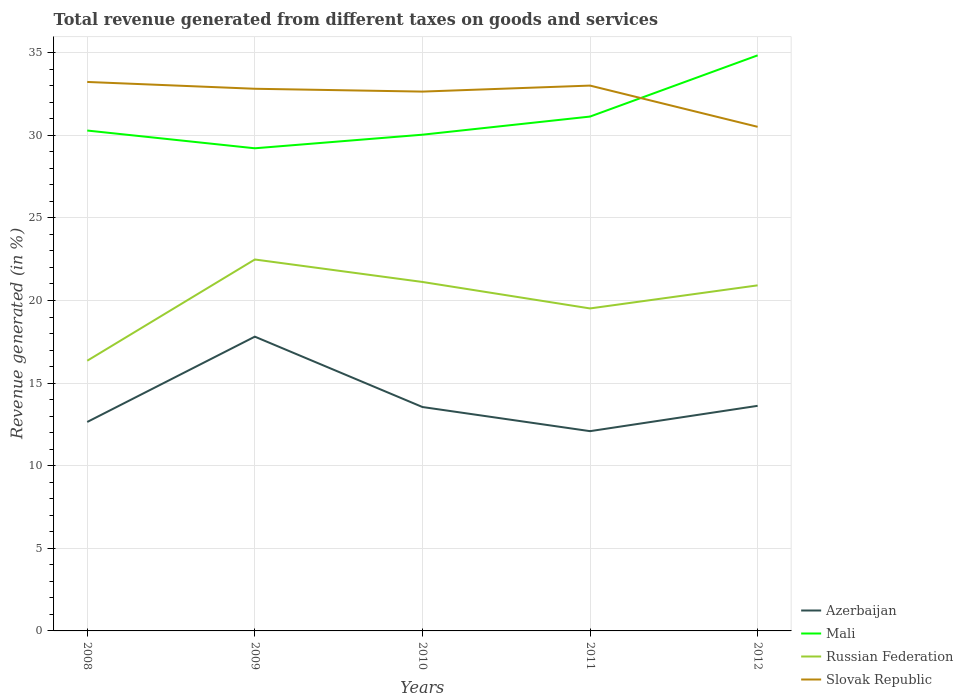How many different coloured lines are there?
Offer a very short reply. 4. Does the line corresponding to Russian Federation intersect with the line corresponding to Slovak Republic?
Keep it short and to the point. No. Across all years, what is the maximum total revenue generated in Mali?
Your answer should be compact. 29.21. In which year was the total revenue generated in Mali maximum?
Offer a very short reply. 2009. What is the total total revenue generated in Slovak Republic in the graph?
Keep it short and to the point. -0.19. What is the difference between the highest and the second highest total revenue generated in Russian Federation?
Ensure brevity in your answer.  6.13. How many lines are there?
Offer a terse response. 4. How many years are there in the graph?
Provide a short and direct response. 5. Are the values on the major ticks of Y-axis written in scientific E-notation?
Keep it short and to the point. No. Does the graph contain any zero values?
Offer a terse response. No. How many legend labels are there?
Keep it short and to the point. 4. How are the legend labels stacked?
Provide a succinct answer. Vertical. What is the title of the graph?
Provide a succinct answer. Total revenue generated from different taxes on goods and services. Does "Peru" appear as one of the legend labels in the graph?
Give a very brief answer. No. What is the label or title of the Y-axis?
Provide a short and direct response. Revenue generated (in %). What is the Revenue generated (in %) of Azerbaijan in 2008?
Your response must be concise. 12.65. What is the Revenue generated (in %) of Mali in 2008?
Offer a terse response. 30.29. What is the Revenue generated (in %) of Russian Federation in 2008?
Ensure brevity in your answer.  16.35. What is the Revenue generated (in %) of Slovak Republic in 2008?
Provide a short and direct response. 33.23. What is the Revenue generated (in %) of Azerbaijan in 2009?
Ensure brevity in your answer.  17.81. What is the Revenue generated (in %) in Mali in 2009?
Keep it short and to the point. 29.21. What is the Revenue generated (in %) of Russian Federation in 2009?
Make the answer very short. 22.48. What is the Revenue generated (in %) of Slovak Republic in 2009?
Keep it short and to the point. 32.82. What is the Revenue generated (in %) in Azerbaijan in 2010?
Make the answer very short. 13.55. What is the Revenue generated (in %) of Mali in 2010?
Your response must be concise. 30.04. What is the Revenue generated (in %) of Russian Federation in 2010?
Provide a succinct answer. 21.12. What is the Revenue generated (in %) in Slovak Republic in 2010?
Your response must be concise. 32.65. What is the Revenue generated (in %) in Azerbaijan in 2011?
Ensure brevity in your answer.  12.09. What is the Revenue generated (in %) in Mali in 2011?
Offer a very short reply. 31.13. What is the Revenue generated (in %) of Russian Federation in 2011?
Your answer should be very brief. 19.52. What is the Revenue generated (in %) of Slovak Republic in 2011?
Make the answer very short. 33.01. What is the Revenue generated (in %) in Azerbaijan in 2012?
Give a very brief answer. 13.63. What is the Revenue generated (in %) of Mali in 2012?
Provide a succinct answer. 34.84. What is the Revenue generated (in %) of Russian Federation in 2012?
Your answer should be very brief. 20.92. What is the Revenue generated (in %) of Slovak Republic in 2012?
Provide a succinct answer. 30.51. Across all years, what is the maximum Revenue generated (in %) in Azerbaijan?
Provide a succinct answer. 17.81. Across all years, what is the maximum Revenue generated (in %) of Mali?
Offer a terse response. 34.84. Across all years, what is the maximum Revenue generated (in %) of Russian Federation?
Your answer should be compact. 22.48. Across all years, what is the maximum Revenue generated (in %) in Slovak Republic?
Offer a terse response. 33.23. Across all years, what is the minimum Revenue generated (in %) of Azerbaijan?
Offer a very short reply. 12.09. Across all years, what is the minimum Revenue generated (in %) of Mali?
Your answer should be compact. 29.21. Across all years, what is the minimum Revenue generated (in %) of Russian Federation?
Your answer should be compact. 16.35. Across all years, what is the minimum Revenue generated (in %) of Slovak Republic?
Your response must be concise. 30.51. What is the total Revenue generated (in %) in Azerbaijan in the graph?
Offer a very short reply. 69.73. What is the total Revenue generated (in %) in Mali in the graph?
Your answer should be very brief. 155.51. What is the total Revenue generated (in %) in Russian Federation in the graph?
Offer a terse response. 100.4. What is the total Revenue generated (in %) of Slovak Republic in the graph?
Make the answer very short. 162.21. What is the difference between the Revenue generated (in %) of Azerbaijan in 2008 and that in 2009?
Make the answer very short. -5.16. What is the difference between the Revenue generated (in %) of Mali in 2008 and that in 2009?
Provide a short and direct response. 1.07. What is the difference between the Revenue generated (in %) in Russian Federation in 2008 and that in 2009?
Give a very brief answer. -6.13. What is the difference between the Revenue generated (in %) of Slovak Republic in 2008 and that in 2009?
Offer a very short reply. 0.41. What is the difference between the Revenue generated (in %) in Azerbaijan in 2008 and that in 2010?
Offer a very short reply. -0.91. What is the difference between the Revenue generated (in %) in Mali in 2008 and that in 2010?
Give a very brief answer. 0.25. What is the difference between the Revenue generated (in %) in Russian Federation in 2008 and that in 2010?
Ensure brevity in your answer.  -4.77. What is the difference between the Revenue generated (in %) in Slovak Republic in 2008 and that in 2010?
Offer a very short reply. 0.58. What is the difference between the Revenue generated (in %) of Azerbaijan in 2008 and that in 2011?
Give a very brief answer. 0.56. What is the difference between the Revenue generated (in %) of Mali in 2008 and that in 2011?
Give a very brief answer. -0.85. What is the difference between the Revenue generated (in %) in Russian Federation in 2008 and that in 2011?
Your answer should be very brief. -3.17. What is the difference between the Revenue generated (in %) in Slovak Republic in 2008 and that in 2011?
Offer a very short reply. 0.22. What is the difference between the Revenue generated (in %) in Azerbaijan in 2008 and that in 2012?
Your answer should be compact. -0.98. What is the difference between the Revenue generated (in %) of Mali in 2008 and that in 2012?
Your response must be concise. -4.55. What is the difference between the Revenue generated (in %) of Russian Federation in 2008 and that in 2012?
Keep it short and to the point. -4.56. What is the difference between the Revenue generated (in %) in Slovak Republic in 2008 and that in 2012?
Your response must be concise. 2.72. What is the difference between the Revenue generated (in %) in Azerbaijan in 2009 and that in 2010?
Ensure brevity in your answer.  4.26. What is the difference between the Revenue generated (in %) of Mali in 2009 and that in 2010?
Keep it short and to the point. -0.82. What is the difference between the Revenue generated (in %) in Russian Federation in 2009 and that in 2010?
Ensure brevity in your answer.  1.36. What is the difference between the Revenue generated (in %) in Slovak Republic in 2009 and that in 2010?
Your response must be concise. 0.17. What is the difference between the Revenue generated (in %) in Azerbaijan in 2009 and that in 2011?
Keep it short and to the point. 5.72. What is the difference between the Revenue generated (in %) in Mali in 2009 and that in 2011?
Make the answer very short. -1.92. What is the difference between the Revenue generated (in %) in Russian Federation in 2009 and that in 2011?
Provide a succinct answer. 2.96. What is the difference between the Revenue generated (in %) of Slovak Republic in 2009 and that in 2011?
Provide a succinct answer. -0.19. What is the difference between the Revenue generated (in %) in Azerbaijan in 2009 and that in 2012?
Give a very brief answer. 4.19. What is the difference between the Revenue generated (in %) in Mali in 2009 and that in 2012?
Offer a terse response. -5.62. What is the difference between the Revenue generated (in %) of Russian Federation in 2009 and that in 2012?
Ensure brevity in your answer.  1.56. What is the difference between the Revenue generated (in %) in Slovak Republic in 2009 and that in 2012?
Provide a succinct answer. 2.3. What is the difference between the Revenue generated (in %) of Azerbaijan in 2010 and that in 2011?
Give a very brief answer. 1.46. What is the difference between the Revenue generated (in %) in Mali in 2010 and that in 2011?
Give a very brief answer. -1.1. What is the difference between the Revenue generated (in %) in Russian Federation in 2010 and that in 2011?
Keep it short and to the point. 1.6. What is the difference between the Revenue generated (in %) of Slovak Republic in 2010 and that in 2011?
Your answer should be very brief. -0.36. What is the difference between the Revenue generated (in %) in Azerbaijan in 2010 and that in 2012?
Your answer should be very brief. -0.07. What is the difference between the Revenue generated (in %) in Mali in 2010 and that in 2012?
Keep it short and to the point. -4.8. What is the difference between the Revenue generated (in %) in Russian Federation in 2010 and that in 2012?
Your response must be concise. 0.2. What is the difference between the Revenue generated (in %) in Slovak Republic in 2010 and that in 2012?
Give a very brief answer. 2.13. What is the difference between the Revenue generated (in %) of Azerbaijan in 2011 and that in 2012?
Give a very brief answer. -1.53. What is the difference between the Revenue generated (in %) in Mali in 2011 and that in 2012?
Make the answer very short. -3.7. What is the difference between the Revenue generated (in %) of Russian Federation in 2011 and that in 2012?
Give a very brief answer. -1.4. What is the difference between the Revenue generated (in %) of Slovak Republic in 2011 and that in 2012?
Your response must be concise. 2.5. What is the difference between the Revenue generated (in %) of Azerbaijan in 2008 and the Revenue generated (in %) of Mali in 2009?
Give a very brief answer. -16.57. What is the difference between the Revenue generated (in %) of Azerbaijan in 2008 and the Revenue generated (in %) of Russian Federation in 2009?
Give a very brief answer. -9.83. What is the difference between the Revenue generated (in %) in Azerbaijan in 2008 and the Revenue generated (in %) in Slovak Republic in 2009?
Offer a very short reply. -20.17. What is the difference between the Revenue generated (in %) in Mali in 2008 and the Revenue generated (in %) in Russian Federation in 2009?
Offer a terse response. 7.81. What is the difference between the Revenue generated (in %) of Mali in 2008 and the Revenue generated (in %) of Slovak Republic in 2009?
Give a very brief answer. -2.53. What is the difference between the Revenue generated (in %) of Russian Federation in 2008 and the Revenue generated (in %) of Slovak Republic in 2009?
Your answer should be very brief. -16.46. What is the difference between the Revenue generated (in %) in Azerbaijan in 2008 and the Revenue generated (in %) in Mali in 2010?
Make the answer very short. -17.39. What is the difference between the Revenue generated (in %) of Azerbaijan in 2008 and the Revenue generated (in %) of Russian Federation in 2010?
Your answer should be very brief. -8.47. What is the difference between the Revenue generated (in %) of Azerbaijan in 2008 and the Revenue generated (in %) of Slovak Republic in 2010?
Provide a short and direct response. -20. What is the difference between the Revenue generated (in %) in Mali in 2008 and the Revenue generated (in %) in Russian Federation in 2010?
Provide a short and direct response. 9.17. What is the difference between the Revenue generated (in %) of Mali in 2008 and the Revenue generated (in %) of Slovak Republic in 2010?
Offer a terse response. -2.36. What is the difference between the Revenue generated (in %) in Russian Federation in 2008 and the Revenue generated (in %) in Slovak Republic in 2010?
Provide a succinct answer. -16.29. What is the difference between the Revenue generated (in %) in Azerbaijan in 2008 and the Revenue generated (in %) in Mali in 2011?
Provide a succinct answer. -18.49. What is the difference between the Revenue generated (in %) of Azerbaijan in 2008 and the Revenue generated (in %) of Russian Federation in 2011?
Ensure brevity in your answer.  -6.87. What is the difference between the Revenue generated (in %) of Azerbaijan in 2008 and the Revenue generated (in %) of Slovak Republic in 2011?
Offer a terse response. -20.36. What is the difference between the Revenue generated (in %) of Mali in 2008 and the Revenue generated (in %) of Russian Federation in 2011?
Ensure brevity in your answer.  10.77. What is the difference between the Revenue generated (in %) in Mali in 2008 and the Revenue generated (in %) in Slovak Republic in 2011?
Offer a terse response. -2.72. What is the difference between the Revenue generated (in %) in Russian Federation in 2008 and the Revenue generated (in %) in Slovak Republic in 2011?
Your answer should be very brief. -16.65. What is the difference between the Revenue generated (in %) of Azerbaijan in 2008 and the Revenue generated (in %) of Mali in 2012?
Offer a very short reply. -22.19. What is the difference between the Revenue generated (in %) of Azerbaijan in 2008 and the Revenue generated (in %) of Russian Federation in 2012?
Keep it short and to the point. -8.27. What is the difference between the Revenue generated (in %) in Azerbaijan in 2008 and the Revenue generated (in %) in Slovak Republic in 2012?
Your answer should be very brief. -17.87. What is the difference between the Revenue generated (in %) of Mali in 2008 and the Revenue generated (in %) of Russian Federation in 2012?
Your answer should be very brief. 9.37. What is the difference between the Revenue generated (in %) of Mali in 2008 and the Revenue generated (in %) of Slovak Republic in 2012?
Make the answer very short. -0.23. What is the difference between the Revenue generated (in %) in Russian Federation in 2008 and the Revenue generated (in %) in Slovak Republic in 2012?
Ensure brevity in your answer.  -14.16. What is the difference between the Revenue generated (in %) in Azerbaijan in 2009 and the Revenue generated (in %) in Mali in 2010?
Your response must be concise. -12.22. What is the difference between the Revenue generated (in %) of Azerbaijan in 2009 and the Revenue generated (in %) of Russian Federation in 2010?
Your response must be concise. -3.31. What is the difference between the Revenue generated (in %) of Azerbaijan in 2009 and the Revenue generated (in %) of Slovak Republic in 2010?
Offer a very short reply. -14.83. What is the difference between the Revenue generated (in %) of Mali in 2009 and the Revenue generated (in %) of Russian Federation in 2010?
Keep it short and to the point. 8.09. What is the difference between the Revenue generated (in %) of Mali in 2009 and the Revenue generated (in %) of Slovak Republic in 2010?
Your answer should be compact. -3.43. What is the difference between the Revenue generated (in %) in Russian Federation in 2009 and the Revenue generated (in %) in Slovak Republic in 2010?
Ensure brevity in your answer.  -10.16. What is the difference between the Revenue generated (in %) in Azerbaijan in 2009 and the Revenue generated (in %) in Mali in 2011?
Offer a very short reply. -13.32. What is the difference between the Revenue generated (in %) in Azerbaijan in 2009 and the Revenue generated (in %) in Russian Federation in 2011?
Keep it short and to the point. -1.71. What is the difference between the Revenue generated (in %) in Azerbaijan in 2009 and the Revenue generated (in %) in Slovak Republic in 2011?
Your response must be concise. -15.2. What is the difference between the Revenue generated (in %) in Mali in 2009 and the Revenue generated (in %) in Russian Federation in 2011?
Your answer should be compact. 9.69. What is the difference between the Revenue generated (in %) in Mali in 2009 and the Revenue generated (in %) in Slovak Republic in 2011?
Offer a very short reply. -3.8. What is the difference between the Revenue generated (in %) of Russian Federation in 2009 and the Revenue generated (in %) of Slovak Republic in 2011?
Ensure brevity in your answer.  -10.53. What is the difference between the Revenue generated (in %) in Azerbaijan in 2009 and the Revenue generated (in %) in Mali in 2012?
Your answer should be very brief. -17.03. What is the difference between the Revenue generated (in %) in Azerbaijan in 2009 and the Revenue generated (in %) in Russian Federation in 2012?
Offer a terse response. -3.11. What is the difference between the Revenue generated (in %) of Azerbaijan in 2009 and the Revenue generated (in %) of Slovak Republic in 2012?
Give a very brief answer. -12.7. What is the difference between the Revenue generated (in %) in Mali in 2009 and the Revenue generated (in %) in Russian Federation in 2012?
Your answer should be very brief. 8.3. What is the difference between the Revenue generated (in %) of Mali in 2009 and the Revenue generated (in %) of Slovak Republic in 2012?
Give a very brief answer. -1.3. What is the difference between the Revenue generated (in %) in Russian Federation in 2009 and the Revenue generated (in %) in Slovak Republic in 2012?
Give a very brief answer. -8.03. What is the difference between the Revenue generated (in %) in Azerbaijan in 2010 and the Revenue generated (in %) in Mali in 2011?
Make the answer very short. -17.58. What is the difference between the Revenue generated (in %) in Azerbaijan in 2010 and the Revenue generated (in %) in Russian Federation in 2011?
Ensure brevity in your answer.  -5.97. What is the difference between the Revenue generated (in %) in Azerbaijan in 2010 and the Revenue generated (in %) in Slovak Republic in 2011?
Your answer should be compact. -19.46. What is the difference between the Revenue generated (in %) of Mali in 2010 and the Revenue generated (in %) of Russian Federation in 2011?
Offer a terse response. 10.52. What is the difference between the Revenue generated (in %) in Mali in 2010 and the Revenue generated (in %) in Slovak Republic in 2011?
Ensure brevity in your answer.  -2.97. What is the difference between the Revenue generated (in %) of Russian Federation in 2010 and the Revenue generated (in %) of Slovak Republic in 2011?
Give a very brief answer. -11.89. What is the difference between the Revenue generated (in %) in Azerbaijan in 2010 and the Revenue generated (in %) in Mali in 2012?
Your response must be concise. -21.29. What is the difference between the Revenue generated (in %) in Azerbaijan in 2010 and the Revenue generated (in %) in Russian Federation in 2012?
Your response must be concise. -7.36. What is the difference between the Revenue generated (in %) in Azerbaijan in 2010 and the Revenue generated (in %) in Slovak Republic in 2012?
Make the answer very short. -16.96. What is the difference between the Revenue generated (in %) of Mali in 2010 and the Revenue generated (in %) of Russian Federation in 2012?
Provide a succinct answer. 9.12. What is the difference between the Revenue generated (in %) of Mali in 2010 and the Revenue generated (in %) of Slovak Republic in 2012?
Provide a short and direct response. -0.48. What is the difference between the Revenue generated (in %) in Russian Federation in 2010 and the Revenue generated (in %) in Slovak Republic in 2012?
Provide a succinct answer. -9.39. What is the difference between the Revenue generated (in %) in Azerbaijan in 2011 and the Revenue generated (in %) in Mali in 2012?
Your answer should be compact. -22.75. What is the difference between the Revenue generated (in %) in Azerbaijan in 2011 and the Revenue generated (in %) in Russian Federation in 2012?
Provide a succinct answer. -8.83. What is the difference between the Revenue generated (in %) in Azerbaijan in 2011 and the Revenue generated (in %) in Slovak Republic in 2012?
Your answer should be compact. -18.42. What is the difference between the Revenue generated (in %) of Mali in 2011 and the Revenue generated (in %) of Russian Federation in 2012?
Provide a short and direct response. 10.22. What is the difference between the Revenue generated (in %) in Mali in 2011 and the Revenue generated (in %) in Slovak Republic in 2012?
Your answer should be compact. 0.62. What is the difference between the Revenue generated (in %) in Russian Federation in 2011 and the Revenue generated (in %) in Slovak Republic in 2012?
Offer a very short reply. -10.99. What is the average Revenue generated (in %) of Azerbaijan per year?
Make the answer very short. 13.95. What is the average Revenue generated (in %) in Mali per year?
Give a very brief answer. 31.1. What is the average Revenue generated (in %) in Russian Federation per year?
Give a very brief answer. 20.08. What is the average Revenue generated (in %) in Slovak Republic per year?
Offer a very short reply. 32.44. In the year 2008, what is the difference between the Revenue generated (in %) of Azerbaijan and Revenue generated (in %) of Mali?
Ensure brevity in your answer.  -17.64. In the year 2008, what is the difference between the Revenue generated (in %) of Azerbaijan and Revenue generated (in %) of Russian Federation?
Provide a succinct answer. -3.71. In the year 2008, what is the difference between the Revenue generated (in %) in Azerbaijan and Revenue generated (in %) in Slovak Republic?
Provide a short and direct response. -20.58. In the year 2008, what is the difference between the Revenue generated (in %) of Mali and Revenue generated (in %) of Russian Federation?
Provide a succinct answer. 13.93. In the year 2008, what is the difference between the Revenue generated (in %) of Mali and Revenue generated (in %) of Slovak Republic?
Offer a terse response. -2.94. In the year 2008, what is the difference between the Revenue generated (in %) in Russian Federation and Revenue generated (in %) in Slovak Republic?
Give a very brief answer. -16.87. In the year 2009, what is the difference between the Revenue generated (in %) of Azerbaijan and Revenue generated (in %) of Mali?
Ensure brevity in your answer.  -11.4. In the year 2009, what is the difference between the Revenue generated (in %) in Azerbaijan and Revenue generated (in %) in Russian Federation?
Make the answer very short. -4.67. In the year 2009, what is the difference between the Revenue generated (in %) in Azerbaijan and Revenue generated (in %) in Slovak Republic?
Offer a terse response. -15. In the year 2009, what is the difference between the Revenue generated (in %) in Mali and Revenue generated (in %) in Russian Federation?
Provide a short and direct response. 6.73. In the year 2009, what is the difference between the Revenue generated (in %) of Mali and Revenue generated (in %) of Slovak Republic?
Give a very brief answer. -3.6. In the year 2009, what is the difference between the Revenue generated (in %) in Russian Federation and Revenue generated (in %) in Slovak Republic?
Provide a short and direct response. -10.33. In the year 2010, what is the difference between the Revenue generated (in %) of Azerbaijan and Revenue generated (in %) of Mali?
Make the answer very short. -16.48. In the year 2010, what is the difference between the Revenue generated (in %) in Azerbaijan and Revenue generated (in %) in Russian Federation?
Provide a succinct answer. -7.57. In the year 2010, what is the difference between the Revenue generated (in %) of Azerbaijan and Revenue generated (in %) of Slovak Republic?
Ensure brevity in your answer.  -19.09. In the year 2010, what is the difference between the Revenue generated (in %) in Mali and Revenue generated (in %) in Russian Federation?
Provide a succinct answer. 8.91. In the year 2010, what is the difference between the Revenue generated (in %) in Mali and Revenue generated (in %) in Slovak Republic?
Your answer should be very brief. -2.61. In the year 2010, what is the difference between the Revenue generated (in %) of Russian Federation and Revenue generated (in %) of Slovak Republic?
Provide a short and direct response. -11.52. In the year 2011, what is the difference between the Revenue generated (in %) in Azerbaijan and Revenue generated (in %) in Mali?
Offer a very short reply. -19.04. In the year 2011, what is the difference between the Revenue generated (in %) in Azerbaijan and Revenue generated (in %) in Russian Federation?
Offer a very short reply. -7.43. In the year 2011, what is the difference between the Revenue generated (in %) of Azerbaijan and Revenue generated (in %) of Slovak Republic?
Keep it short and to the point. -20.92. In the year 2011, what is the difference between the Revenue generated (in %) in Mali and Revenue generated (in %) in Russian Federation?
Keep it short and to the point. 11.61. In the year 2011, what is the difference between the Revenue generated (in %) of Mali and Revenue generated (in %) of Slovak Republic?
Keep it short and to the point. -1.88. In the year 2011, what is the difference between the Revenue generated (in %) of Russian Federation and Revenue generated (in %) of Slovak Republic?
Offer a terse response. -13.49. In the year 2012, what is the difference between the Revenue generated (in %) of Azerbaijan and Revenue generated (in %) of Mali?
Your answer should be compact. -21.21. In the year 2012, what is the difference between the Revenue generated (in %) in Azerbaijan and Revenue generated (in %) in Russian Federation?
Provide a succinct answer. -7.29. In the year 2012, what is the difference between the Revenue generated (in %) of Azerbaijan and Revenue generated (in %) of Slovak Republic?
Your response must be concise. -16.89. In the year 2012, what is the difference between the Revenue generated (in %) in Mali and Revenue generated (in %) in Russian Federation?
Make the answer very short. 13.92. In the year 2012, what is the difference between the Revenue generated (in %) in Mali and Revenue generated (in %) in Slovak Republic?
Your answer should be very brief. 4.32. In the year 2012, what is the difference between the Revenue generated (in %) of Russian Federation and Revenue generated (in %) of Slovak Republic?
Ensure brevity in your answer.  -9.6. What is the ratio of the Revenue generated (in %) of Azerbaijan in 2008 to that in 2009?
Provide a succinct answer. 0.71. What is the ratio of the Revenue generated (in %) in Mali in 2008 to that in 2009?
Offer a very short reply. 1.04. What is the ratio of the Revenue generated (in %) of Russian Federation in 2008 to that in 2009?
Give a very brief answer. 0.73. What is the ratio of the Revenue generated (in %) of Slovak Republic in 2008 to that in 2009?
Give a very brief answer. 1.01. What is the ratio of the Revenue generated (in %) in Azerbaijan in 2008 to that in 2010?
Your answer should be very brief. 0.93. What is the ratio of the Revenue generated (in %) in Mali in 2008 to that in 2010?
Your response must be concise. 1.01. What is the ratio of the Revenue generated (in %) in Russian Federation in 2008 to that in 2010?
Make the answer very short. 0.77. What is the ratio of the Revenue generated (in %) of Slovak Republic in 2008 to that in 2010?
Ensure brevity in your answer.  1.02. What is the ratio of the Revenue generated (in %) in Azerbaijan in 2008 to that in 2011?
Give a very brief answer. 1.05. What is the ratio of the Revenue generated (in %) of Mali in 2008 to that in 2011?
Your answer should be compact. 0.97. What is the ratio of the Revenue generated (in %) of Russian Federation in 2008 to that in 2011?
Make the answer very short. 0.84. What is the ratio of the Revenue generated (in %) in Slovak Republic in 2008 to that in 2011?
Provide a short and direct response. 1.01. What is the ratio of the Revenue generated (in %) of Azerbaijan in 2008 to that in 2012?
Keep it short and to the point. 0.93. What is the ratio of the Revenue generated (in %) in Mali in 2008 to that in 2012?
Your response must be concise. 0.87. What is the ratio of the Revenue generated (in %) in Russian Federation in 2008 to that in 2012?
Your answer should be very brief. 0.78. What is the ratio of the Revenue generated (in %) of Slovak Republic in 2008 to that in 2012?
Your answer should be very brief. 1.09. What is the ratio of the Revenue generated (in %) of Azerbaijan in 2009 to that in 2010?
Your answer should be compact. 1.31. What is the ratio of the Revenue generated (in %) of Mali in 2009 to that in 2010?
Make the answer very short. 0.97. What is the ratio of the Revenue generated (in %) of Russian Federation in 2009 to that in 2010?
Your answer should be compact. 1.06. What is the ratio of the Revenue generated (in %) in Slovak Republic in 2009 to that in 2010?
Provide a succinct answer. 1.01. What is the ratio of the Revenue generated (in %) of Azerbaijan in 2009 to that in 2011?
Your answer should be compact. 1.47. What is the ratio of the Revenue generated (in %) of Mali in 2009 to that in 2011?
Make the answer very short. 0.94. What is the ratio of the Revenue generated (in %) of Russian Federation in 2009 to that in 2011?
Your answer should be compact. 1.15. What is the ratio of the Revenue generated (in %) of Slovak Republic in 2009 to that in 2011?
Your response must be concise. 0.99. What is the ratio of the Revenue generated (in %) of Azerbaijan in 2009 to that in 2012?
Offer a very short reply. 1.31. What is the ratio of the Revenue generated (in %) of Mali in 2009 to that in 2012?
Offer a very short reply. 0.84. What is the ratio of the Revenue generated (in %) in Russian Federation in 2009 to that in 2012?
Your answer should be very brief. 1.07. What is the ratio of the Revenue generated (in %) of Slovak Republic in 2009 to that in 2012?
Ensure brevity in your answer.  1.08. What is the ratio of the Revenue generated (in %) of Azerbaijan in 2010 to that in 2011?
Provide a short and direct response. 1.12. What is the ratio of the Revenue generated (in %) of Mali in 2010 to that in 2011?
Keep it short and to the point. 0.96. What is the ratio of the Revenue generated (in %) of Russian Federation in 2010 to that in 2011?
Offer a very short reply. 1.08. What is the ratio of the Revenue generated (in %) of Azerbaijan in 2010 to that in 2012?
Ensure brevity in your answer.  0.99. What is the ratio of the Revenue generated (in %) in Mali in 2010 to that in 2012?
Make the answer very short. 0.86. What is the ratio of the Revenue generated (in %) in Russian Federation in 2010 to that in 2012?
Your response must be concise. 1.01. What is the ratio of the Revenue generated (in %) in Slovak Republic in 2010 to that in 2012?
Your answer should be very brief. 1.07. What is the ratio of the Revenue generated (in %) in Azerbaijan in 2011 to that in 2012?
Keep it short and to the point. 0.89. What is the ratio of the Revenue generated (in %) of Mali in 2011 to that in 2012?
Offer a terse response. 0.89. What is the ratio of the Revenue generated (in %) in Russian Federation in 2011 to that in 2012?
Ensure brevity in your answer.  0.93. What is the ratio of the Revenue generated (in %) of Slovak Republic in 2011 to that in 2012?
Keep it short and to the point. 1.08. What is the difference between the highest and the second highest Revenue generated (in %) in Azerbaijan?
Provide a succinct answer. 4.19. What is the difference between the highest and the second highest Revenue generated (in %) of Mali?
Your answer should be compact. 3.7. What is the difference between the highest and the second highest Revenue generated (in %) of Russian Federation?
Your answer should be compact. 1.36. What is the difference between the highest and the second highest Revenue generated (in %) in Slovak Republic?
Make the answer very short. 0.22. What is the difference between the highest and the lowest Revenue generated (in %) of Azerbaijan?
Your answer should be compact. 5.72. What is the difference between the highest and the lowest Revenue generated (in %) in Mali?
Provide a short and direct response. 5.62. What is the difference between the highest and the lowest Revenue generated (in %) of Russian Federation?
Offer a terse response. 6.13. What is the difference between the highest and the lowest Revenue generated (in %) of Slovak Republic?
Your answer should be very brief. 2.72. 